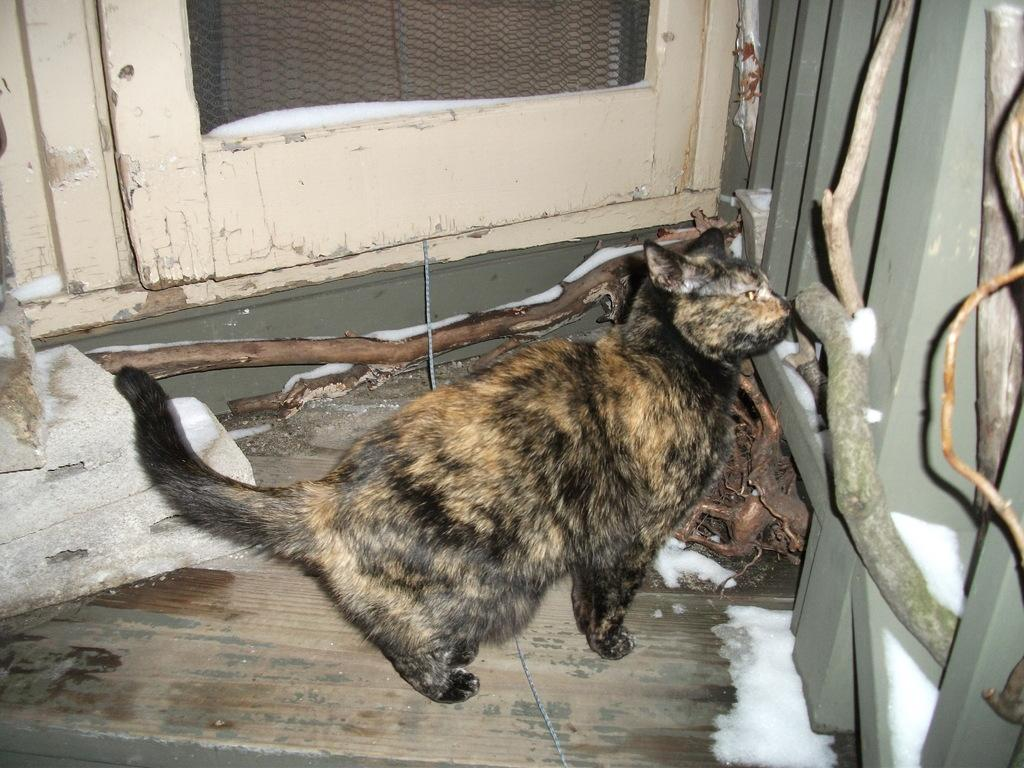What type of animal is in the image? There is a cat in the image. What is located behind the cat? There is a door behind the cat. What can be seen on the right side of the image? There is a railing on the right side of the image. What type of fiction is the cat reading in the image? There is no book or any form of fiction present in the image; it only features a cat, a door, and a railing. 